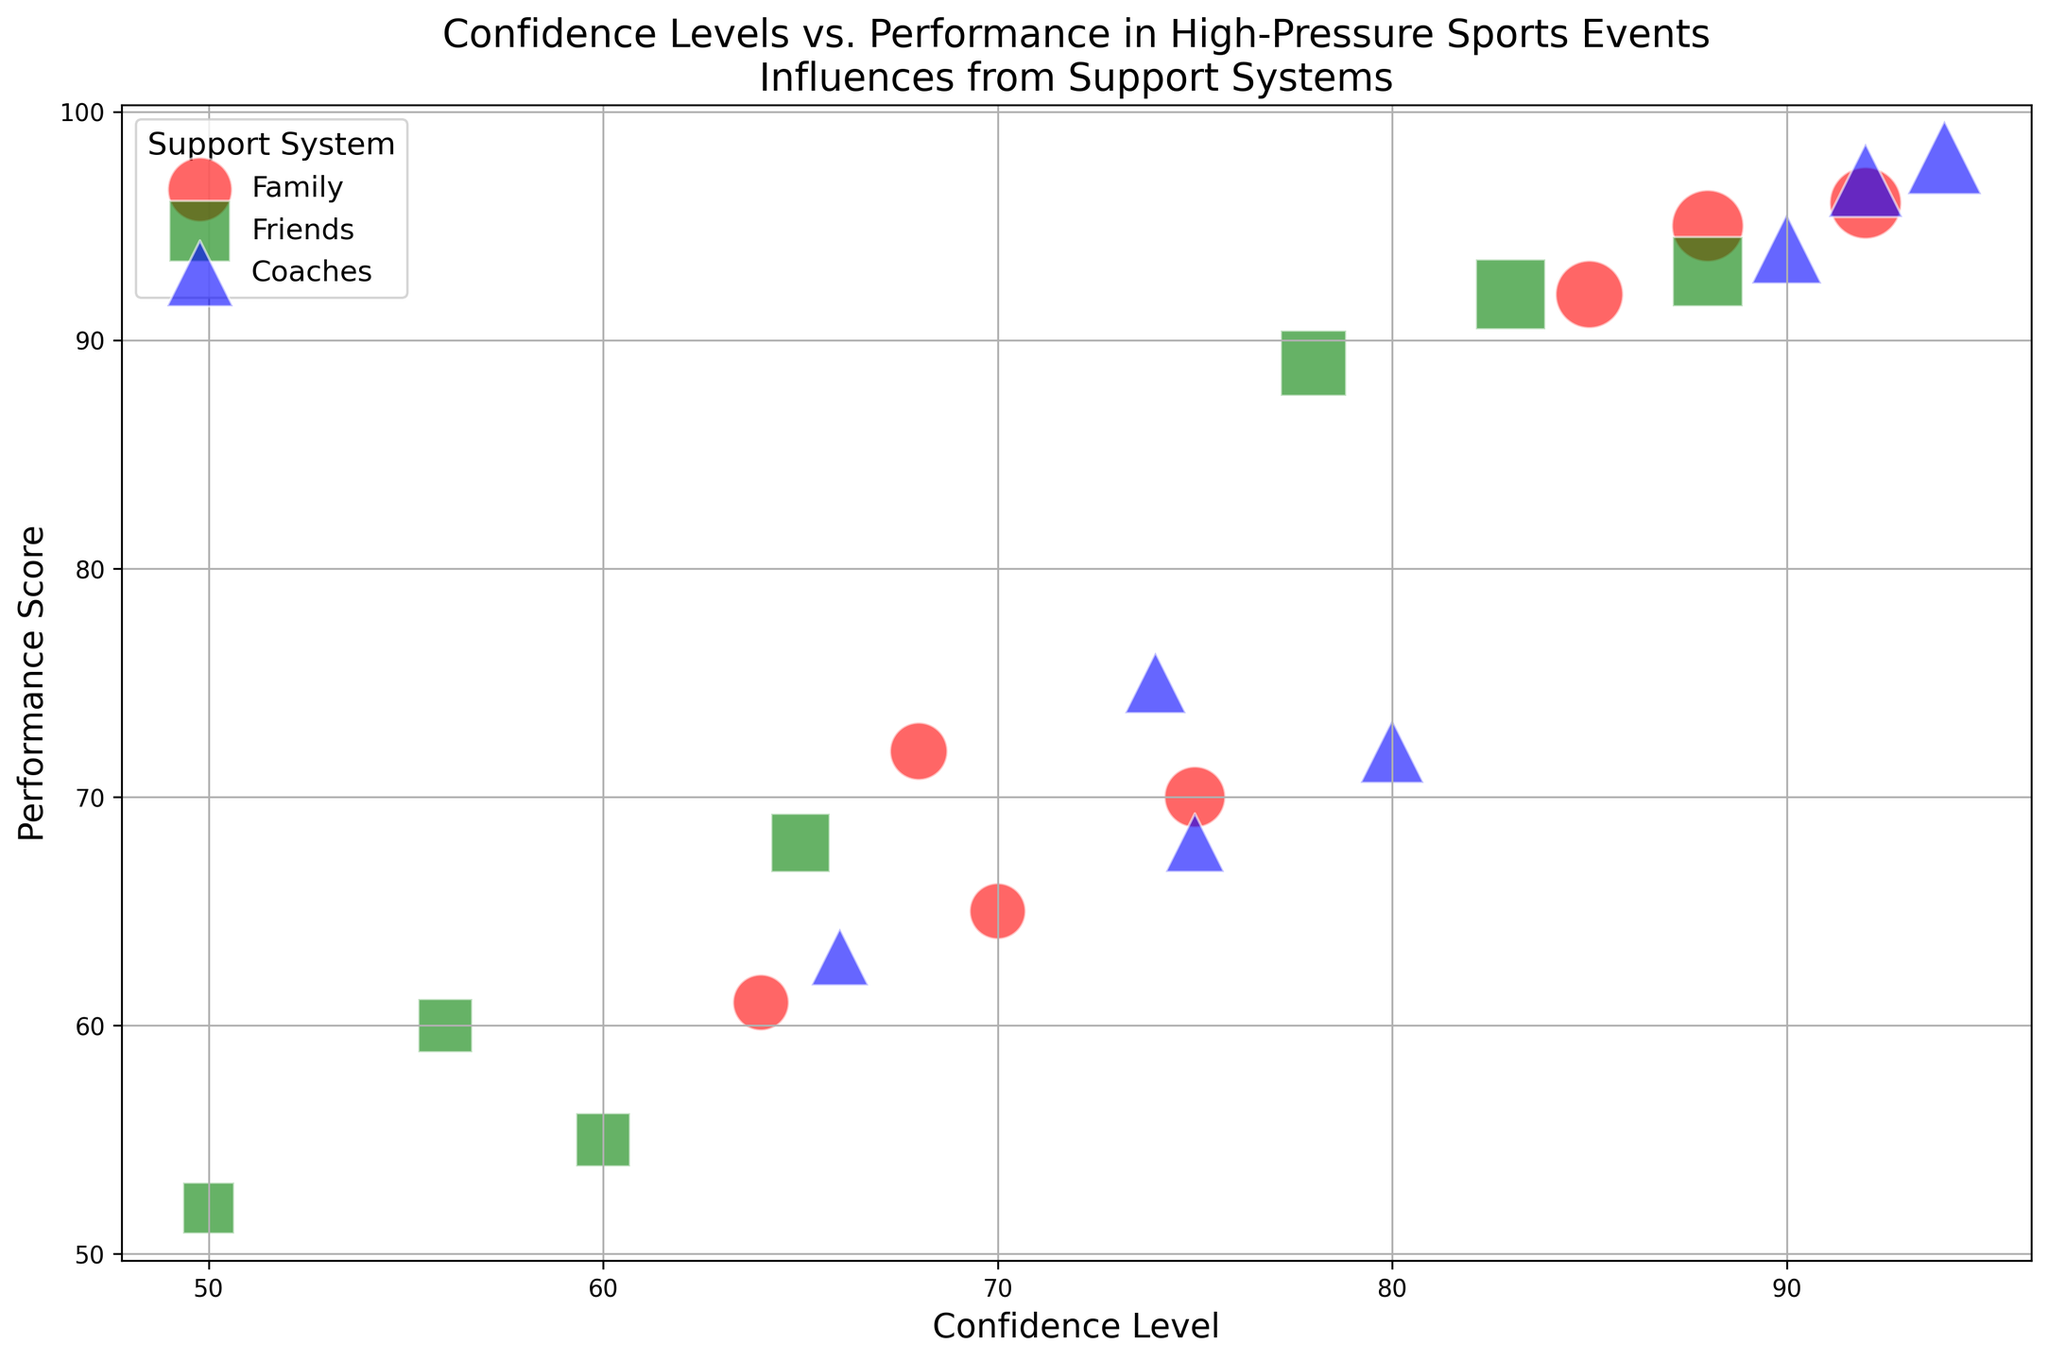What event has the highest performance score for athletes with support from friends? First, identify bubbles representing "Friends" support in the figure, which are green squares. Then, locate the highest point on the y-axis among those green squares. The highest performance score for "Friends" is 93, which occurs at the International Championship event.
Answer: International Championship Comparing support systems, which type shows the highest overall performance scores? Look at the bubble positions on the y-axis for each color and shape: red circles for "Family", green squares for "Friends", and blue triangles for "Coaches". The highest bubbles overall are blue triangles, indicating "Coaches" consistently show higher performance scores.
Answer: Coaches What's the average confidence level for performances supported by friends across all events? Identify green square bubbles indicating "Friends" support and note their x-axis positions. The confidence levels are 78, 65, 60, 83, 56, 50, and 88. Sum these values: 78 + 65 + 60 + 83 + 56 + 50 + 88 = 480. Divide by the number of data points (7), which is 480/7.
Answer: 68.57 Which support system type has the largest representation at the Olympic Trials? Locate the section of the plot titled "Olympic Trials" and count the bubbles for each color and shape. There are 3 bubbles for each support type (Family, Friends, Coaches). Thus, all support systems have equal representation.
Answer: All equal Are confidence levels generally higher for events with scoring over 90, and which support system is the most common in these cases? Identify bubbles with performance scores over 90 on the y-axis, then compare their x-axis positions (confidence levels). Higher confidence levels mostly correspond to "Coaches" (blue triangles) and "Family" (red circles). Both are common for high performance, but "Coaches" slightly more.
Answer: Yes, Coaches What influences the bubble size and which support type has the largest bubbles overall? Bubble size is influenced by "Support System Strength". On average, larger bubbles (size) are blue triangles representing "Coaches".
Answer: Coaches For the State Meet, which support system results in the highest confidence level? Focus on the "State Meet" section and identify the bubbles for each support system type. The highest confidence level (75) is represented by a blue triangle, indicating "Coaches".
Answer: Coaches How does support system strength correlate with performance scores in the National Championship? Compare bubble sizes (indicating support system strength) with y-axis positions for "National Championship". Larger bubble sizes (higher support) generally show higher performance scores, especially noticeable in blue triangles (Coaches).
Answer: Positive correlation 